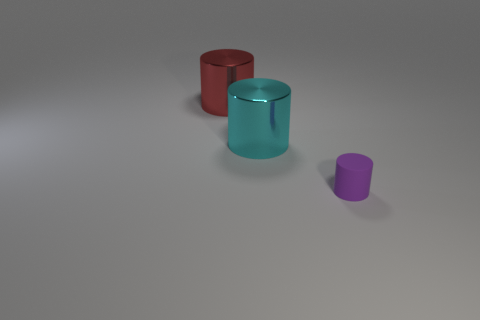Subtract all large cyan metal cylinders. How many cylinders are left? 2 Add 3 small cylinders. How many objects exist? 6 Subtract all cyan cylinders. How many cylinders are left? 2 Subtract 1 cylinders. How many cylinders are left? 2 Subtract all green blocks. How many brown cylinders are left? 0 Subtract all purple blocks. Subtract all big metal cylinders. How many objects are left? 1 Add 2 cyan cylinders. How many cyan cylinders are left? 3 Add 2 cylinders. How many cylinders exist? 5 Subtract 0 cyan balls. How many objects are left? 3 Subtract all cyan cylinders. Subtract all purple balls. How many cylinders are left? 2 